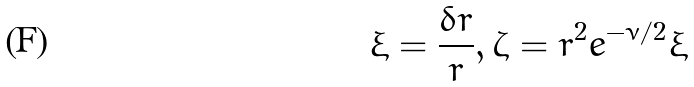Convert formula to latex. <formula><loc_0><loc_0><loc_500><loc_500>\xi = \frac { { \delta } r } { r } , \zeta = r ^ { 2 } e ^ { - \nu / 2 } \xi</formula> 